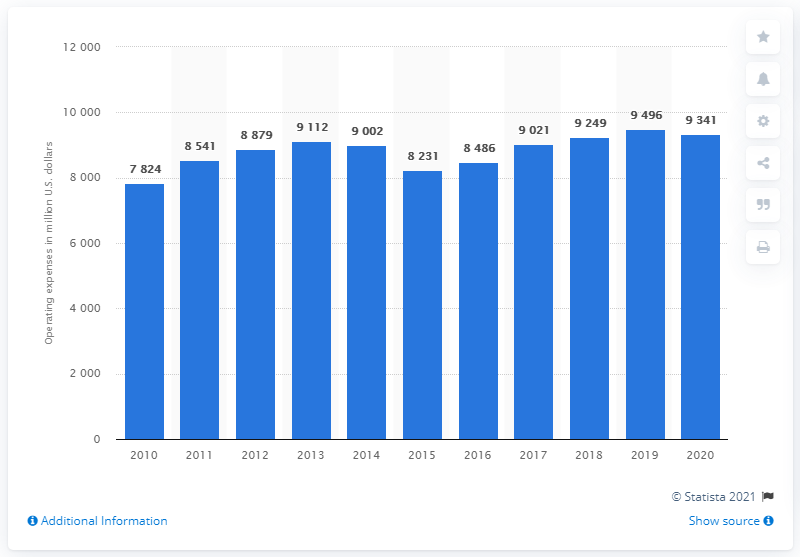Highlight a few significant elements in this photo. Waste Management, Inc reported operating expenses of $9,341 for the year ended December 31, 2020. 